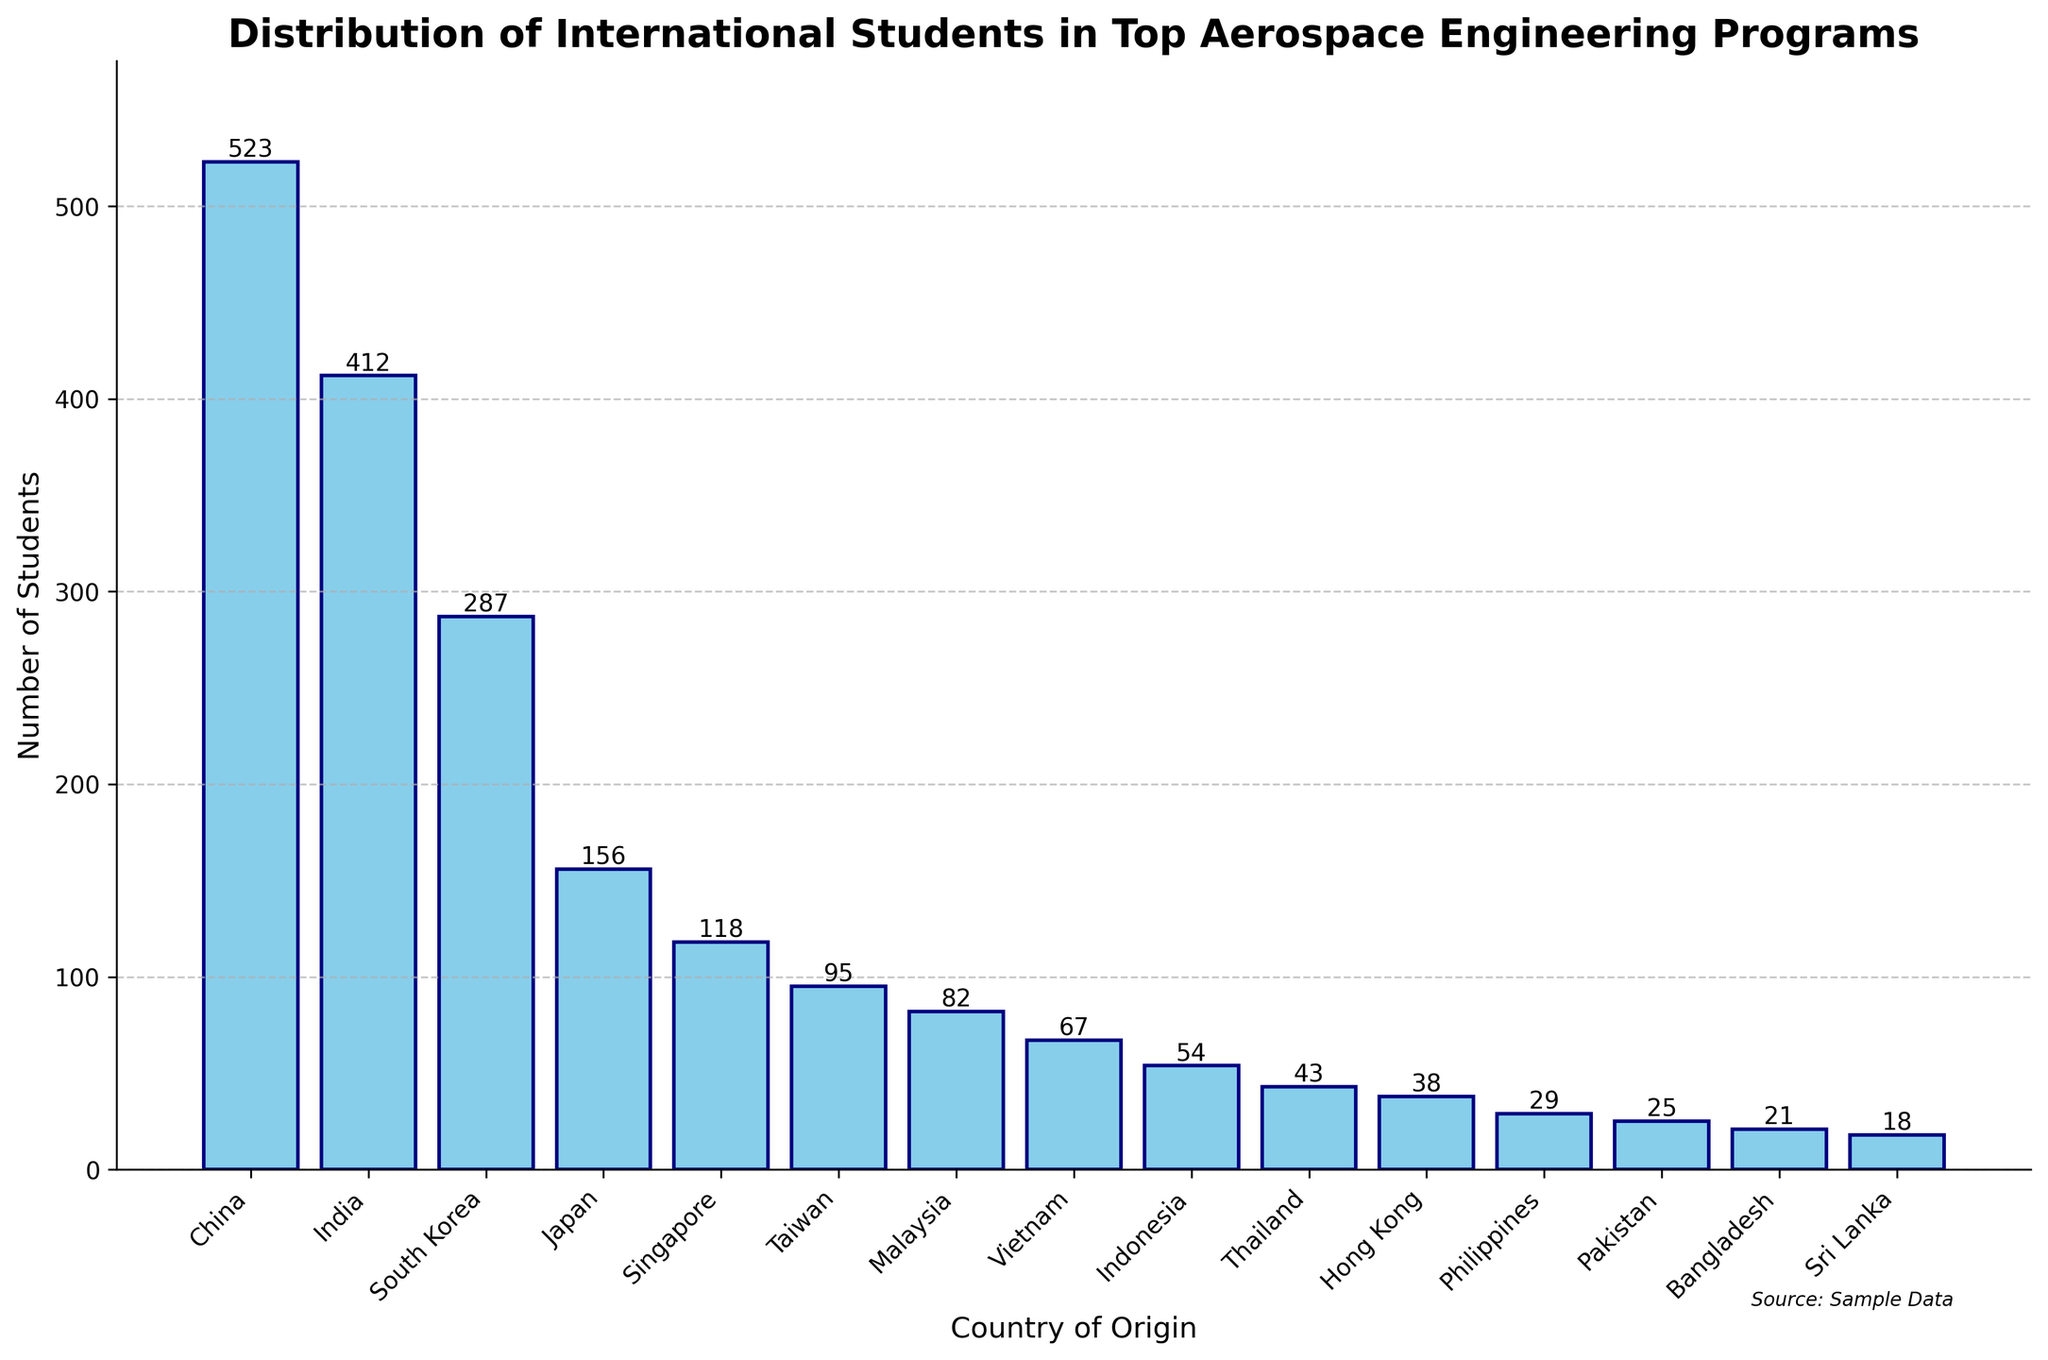Which country has the highest number of international students in top aerospace engineering programs? By examining the heights of the bars, it's evident that the bar representing China is the tallest. The exact value shown on top of this bar is 523, indicating that China has the highest number of international students.
Answer: China What is the total number of students from Japan and Singapore combined? To find the sum of the students from Japan and Singapore, look at the heights of their respective bars. The values shown on these bars are 156 for Japan and 118 for Singapore. Adding these values, we get 156 + 118 = 274.
Answer: 274 Which country has fewer international students, Taiwan or Malaysia? By comparing the heights of the bars for Taiwan and Malaysia, we see that the bar for Taiwan is shorter. The exact values are 95 for Taiwan and 82 for Malaysia. Since 82 is less than 95, Malaysia has fewer international students.
Answer: Malaysia What is the difference in the number of students between South Korea and Vietnam? To find the difference, refer to the heights of the bars for South Korea and Vietnam, which are 287 and 67 respectively. Subtracting these values, we get 287 - 67 = 220.
Answer: 220 How many countries have more than 100 international students? Scan the figure and count the bars that have values greater than 100. The countries are China (523), India (412), South Korea (287), Japan (156), and Singapore (118). This results in 5 countries.
Answer: 5 What's the average number of students from Bangladesh, Sri Lanka, and the Philippines? First, sum the values from these countries: Bangladesh (21), Sri Lanka (18), and the Philippines (29). The total is 21 + 18 + 29 = 68. Then, since there are three countries, divide by 3, so 68 / 3 ≈ 22.67.
Answer: 22.67 Which country has a higher number of students: Indonesia or Thailand? Compare the heights of the bars for Indonesia and Thailand. The values are 54 for Indonesia and 43 for Thailand. Since 54 is greater than 43, Indonesia has a higher number of students.
Answer: Indonesia  Both differences are the same, so the number of students from Pakistan is equally close to the number of students from Bangladesh and the Philippines.
Answer: equally close 